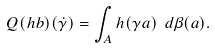Convert formula to latex. <formula><loc_0><loc_0><loc_500><loc_500>Q ( h b ) ( \dot { \gamma } ) = \int _ { A } h ( \gamma a ) \ d \beta ( a ) .</formula> 